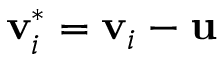<formula> <loc_0><loc_0><loc_500><loc_500>v _ { i } ^ { * } = v _ { i } - u</formula> 